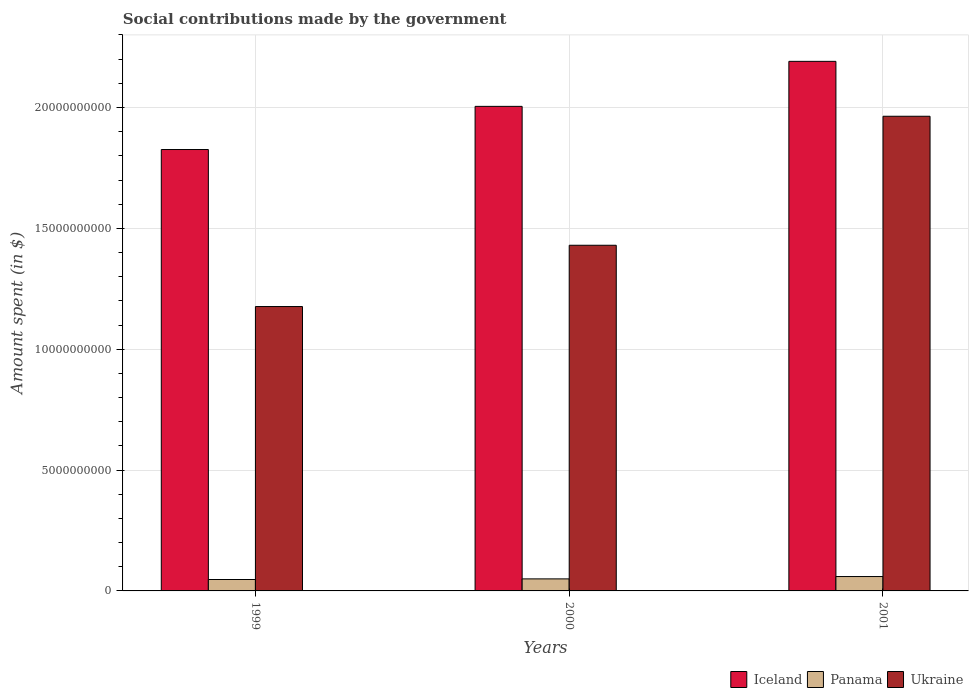How many groups of bars are there?
Provide a succinct answer. 3. What is the label of the 3rd group of bars from the left?
Your answer should be very brief. 2001. In how many cases, is the number of bars for a given year not equal to the number of legend labels?
Keep it short and to the point. 0. What is the amount spent on social contributions in Ukraine in 2000?
Keep it short and to the point. 1.43e+1. Across all years, what is the maximum amount spent on social contributions in Iceland?
Offer a terse response. 2.19e+1. Across all years, what is the minimum amount spent on social contributions in Ukraine?
Make the answer very short. 1.18e+1. In which year was the amount spent on social contributions in Panama maximum?
Offer a terse response. 2001. What is the total amount spent on social contributions in Panama in the graph?
Offer a very short reply. 1.56e+09. What is the difference between the amount spent on social contributions in Ukraine in 2000 and that in 2001?
Give a very brief answer. -5.34e+09. What is the difference between the amount spent on social contributions in Ukraine in 2000 and the amount spent on social contributions in Iceland in 2001?
Keep it short and to the point. -7.61e+09. What is the average amount spent on social contributions in Ukraine per year?
Offer a very short reply. 1.52e+1. In the year 2001, what is the difference between the amount spent on social contributions in Iceland and amount spent on social contributions in Ukraine?
Provide a short and direct response. 2.27e+09. In how many years, is the amount spent on social contributions in Iceland greater than 15000000000 $?
Your response must be concise. 3. What is the ratio of the amount spent on social contributions in Ukraine in 1999 to that in 2000?
Offer a very short reply. 0.82. What is the difference between the highest and the second highest amount spent on social contributions in Iceland?
Ensure brevity in your answer.  1.86e+09. What is the difference between the highest and the lowest amount spent on social contributions in Panama?
Provide a short and direct response. 1.23e+08. In how many years, is the amount spent on social contributions in Ukraine greater than the average amount spent on social contributions in Ukraine taken over all years?
Give a very brief answer. 1. What does the 2nd bar from the left in 2000 represents?
Ensure brevity in your answer.  Panama. What does the 1st bar from the right in 1999 represents?
Make the answer very short. Ukraine. Is it the case that in every year, the sum of the amount spent on social contributions in Ukraine and amount spent on social contributions in Iceland is greater than the amount spent on social contributions in Panama?
Provide a short and direct response. Yes. Are all the bars in the graph horizontal?
Provide a short and direct response. No. How many years are there in the graph?
Provide a short and direct response. 3. What is the difference between two consecutive major ticks on the Y-axis?
Your answer should be very brief. 5.00e+09. Does the graph contain any zero values?
Provide a short and direct response. No. Where does the legend appear in the graph?
Ensure brevity in your answer.  Bottom right. How many legend labels are there?
Give a very brief answer. 3. How are the legend labels stacked?
Provide a short and direct response. Horizontal. What is the title of the graph?
Your response must be concise. Social contributions made by the government. Does "Monaco" appear as one of the legend labels in the graph?
Give a very brief answer. No. What is the label or title of the X-axis?
Provide a succinct answer. Years. What is the label or title of the Y-axis?
Your response must be concise. Amount spent (in $). What is the Amount spent (in $) of Iceland in 1999?
Ensure brevity in your answer.  1.83e+1. What is the Amount spent (in $) of Panama in 1999?
Ensure brevity in your answer.  4.72e+08. What is the Amount spent (in $) in Ukraine in 1999?
Give a very brief answer. 1.18e+1. What is the Amount spent (in $) in Iceland in 2000?
Provide a succinct answer. 2.00e+1. What is the Amount spent (in $) in Panama in 2000?
Provide a short and direct response. 4.98e+08. What is the Amount spent (in $) of Ukraine in 2000?
Your answer should be compact. 1.43e+1. What is the Amount spent (in $) in Iceland in 2001?
Offer a very short reply. 2.19e+1. What is the Amount spent (in $) in Panama in 2001?
Make the answer very short. 5.95e+08. What is the Amount spent (in $) in Ukraine in 2001?
Your response must be concise. 1.96e+1. Across all years, what is the maximum Amount spent (in $) of Iceland?
Give a very brief answer. 2.19e+1. Across all years, what is the maximum Amount spent (in $) in Panama?
Your response must be concise. 5.95e+08. Across all years, what is the maximum Amount spent (in $) of Ukraine?
Offer a terse response. 1.96e+1. Across all years, what is the minimum Amount spent (in $) in Iceland?
Keep it short and to the point. 1.83e+1. Across all years, what is the minimum Amount spent (in $) in Panama?
Provide a short and direct response. 4.72e+08. Across all years, what is the minimum Amount spent (in $) in Ukraine?
Offer a terse response. 1.18e+1. What is the total Amount spent (in $) in Iceland in the graph?
Your answer should be very brief. 6.02e+1. What is the total Amount spent (in $) of Panama in the graph?
Your response must be concise. 1.56e+09. What is the total Amount spent (in $) of Ukraine in the graph?
Provide a short and direct response. 4.57e+1. What is the difference between the Amount spent (in $) of Iceland in 1999 and that in 2000?
Offer a very short reply. -1.79e+09. What is the difference between the Amount spent (in $) in Panama in 1999 and that in 2000?
Offer a terse response. -2.57e+07. What is the difference between the Amount spent (in $) in Ukraine in 1999 and that in 2000?
Your answer should be compact. -2.54e+09. What is the difference between the Amount spent (in $) in Iceland in 1999 and that in 2001?
Make the answer very short. -3.65e+09. What is the difference between the Amount spent (in $) of Panama in 1999 and that in 2001?
Your response must be concise. -1.23e+08. What is the difference between the Amount spent (in $) of Ukraine in 1999 and that in 2001?
Your answer should be very brief. -7.87e+09. What is the difference between the Amount spent (in $) of Iceland in 2000 and that in 2001?
Your answer should be compact. -1.86e+09. What is the difference between the Amount spent (in $) in Panama in 2000 and that in 2001?
Your answer should be compact. -9.71e+07. What is the difference between the Amount spent (in $) in Ukraine in 2000 and that in 2001?
Give a very brief answer. -5.34e+09. What is the difference between the Amount spent (in $) in Iceland in 1999 and the Amount spent (in $) in Panama in 2000?
Provide a short and direct response. 1.78e+1. What is the difference between the Amount spent (in $) in Iceland in 1999 and the Amount spent (in $) in Ukraine in 2000?
Offer a very short reply. 3.96e+09. What is the difference between the Amount spent (in $) in Panama in 1999 and the Amount spent (in $) in Ukraine in 2000?
Ensure brevity in your answer.  -1.38e+1. What is the difference between the Amount spent (in $) in Iceland in 1999 and the Amount spent (in $) in Panama in 2001?
Offer a terse response. 1.77e+1. What is the difference between the Amount spent (in $) in Iceland in 1999 and the Amount spent (in $) in Ukraine in 2001?
Make the answer very short. -1.38e+09. What is the difference between the Amount spent (in $) in Panama in 1999 and the Amount spent (in $) in Ukraine in 2001?
Make the answer very short. -1.92e+1. What is the difference between the Amount spent (in $) in Iceland in 2000 and the Amount spent (in $) in Panama in 2001?
Provide a succinct answer. 1.95e+1. What is the difference between the Amount spent (in $) in Iceland in 2000 and the Amount spent (in $) in Ukraine in 2001?
Provide a short and direct response. 4.09e+08. What is the difference between the Amount spent (in $) in Panama in 2000 and the Amount spent (in $) in Ukraine in 2001?
Provide a succinct answer. -1.91e+1. What is the average Amount spent (in $) in Iceland per year?
Your answer should be compact. 2.01e+1. What is the average Amount spent (in $) of Panama per year?
Offer a terse response. 5.22e+08. What is the average Amount spent (in $) in Ukraine per year?
Your response must be concise. 1.52e+1. In the year 1999, what is the difference between the Amount spent (in $) of Iceland and Amount spent (in $) of Panama?
Give a very brief answer. 1.78e+1. In the year 1999, what is the difference between the Amount spent (in $) of Iceland and Amount spent (in $) of Ukraine?
Provide a short and direct response. 6.50e+09. In the year 1999, what is the difference between the Amount spent (in $) of Panama and Amount spent (in $) of Ukraine?
Make the answer very short. -1.13e+1. In the year 2000, what is the difference between the Amount spent (in $) of Iceland and Amount spent (in $) of Panama?
Ensure brevity in your answer.  1.95e+1. In the year 2000, what is the difference between the Amount spent (in $) of Iceland and Amount spent (in $) of Ukraine?
Keep it short and to the point. 5.75e+09. In the year 2000, what is the difference between the Amount spent (in $) of Panama and Amount spent (in $) of Ukraine?
Provide a succinct answer. -1.38e+1. In the year 2001, what is the difference between the Amount spent (in $) of Iceland and Amount spent (in $) of Panama?
Make the answer very short. 2.13e+1. In the year 2001, what is the difference between the Amount spent (in $) of Iceland and Amount spent (in $) of Ukraine?
Provide a succinct answer. 2.27e+09. In the year 2001, what is the difference between the Amount spent (in $) in Panama and Amount spent (in $) in Ukraine?
Your answer should be very brief. -1.90e+1. What is the ratio of the Amount spent (in $) in Iceland in 1999 to that in 2000?
Your response must be concise. 0.91. What is the ratio of the Amount spent (in $) in Panama in 1999 to that in 2000?
Provide a succinct answer. 0.95. What is the ratio of the Amount spent (in $) in Ukraine in 1999 to that in 2000?
Ensure brevity in your answer.  0.82. What is the ratio of the Amount spent (in $) in Iceland in 1999 to that in 2001?
Keep it short and to the point. 0.83. What is the ratio of the Amount spent (in $) in Panama in 1999 to that in 2001?
Your response must be concise. 0.79. What is the ratio of the Amount spent (in $) in Ukraine in 1999 to that in 2001?
Offer a terse response. 0.6. What is the ratio of the Amount spent (in $) of Iceland in 2000 to that in 2001?
Keep it short and to the point. 0.92. What is the ratio of the Amount spent (in $) in Panama in 2000 to that in 2001?
Give a very brief answer. 0.84. What is the ratio of the Amount spent (in $) of Ukraine in 2000 to that in 2001?
Offer a very short reply. 0.73. What is the difference between the highest and the second highest Amount spent (in $) in Iceland?
Keep it short and to the point. 1.86e+09. What is the difference between the highest and the second highest Amount spent (in $) in Panama?
Provide a succinct answer. 9.71e+07. What is the difference between the highest and the second highest Amount spent (in $) of Ukraine?
Ensure brevity in your answer.  5.34e+09. What is the difference between the highest and the lowest Amount spent (in $) in Iceland?
Offer a very short reply. 3.65e+09. What is the difference between the highest and the lowest Amount spent (in $) in Panama?
Provide a short and direct response. 1.23e+08. What is the difference between the highest and the lowest Amount spent (in $) of Ukraine?
Keep it short and to the point. 7.87e+09. 